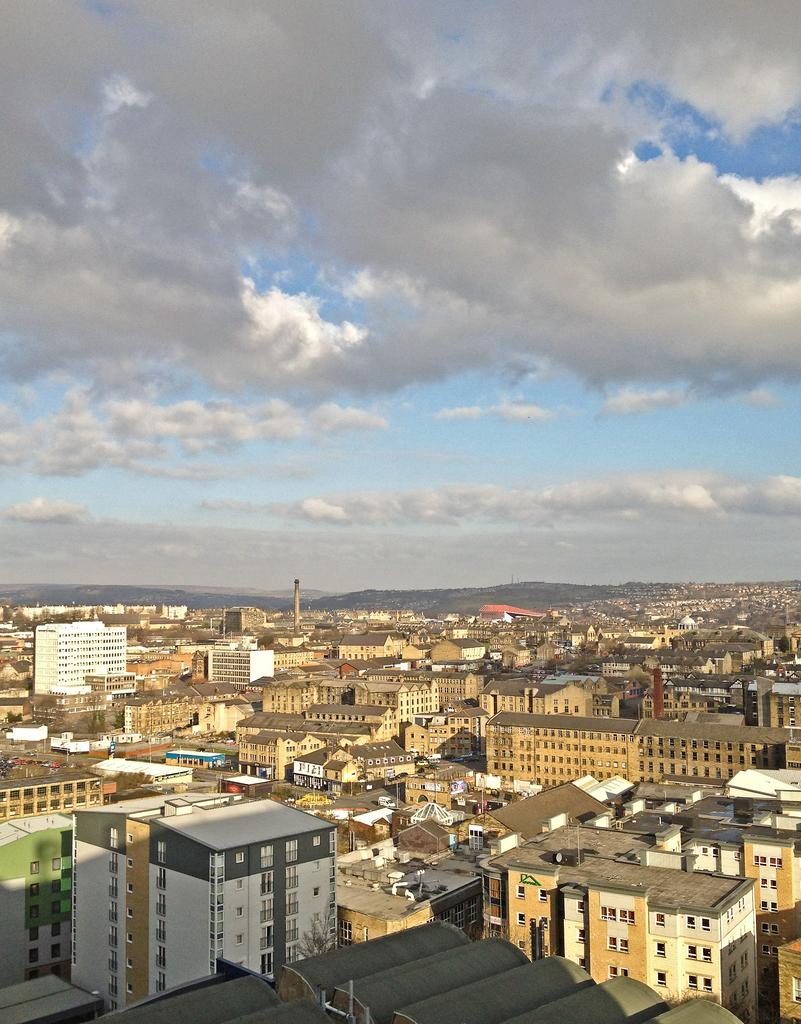What type of structures can be seen in the image? There are buildings in the image. What can be observed in the sky in the image? There are clouds in the sky. How many gloves can be seen on the floor in the image? There are no gloves present in the image; it only features buildings and clouds in the sky. 